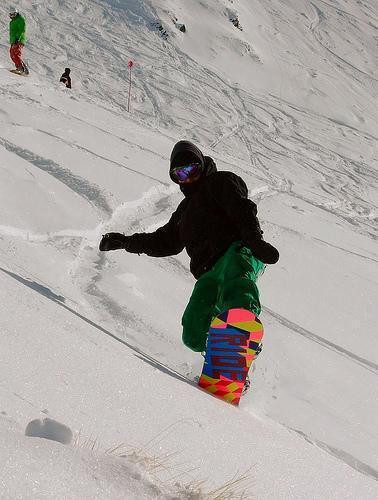How many flags are in the background?
Give a very brief answer. 1. 